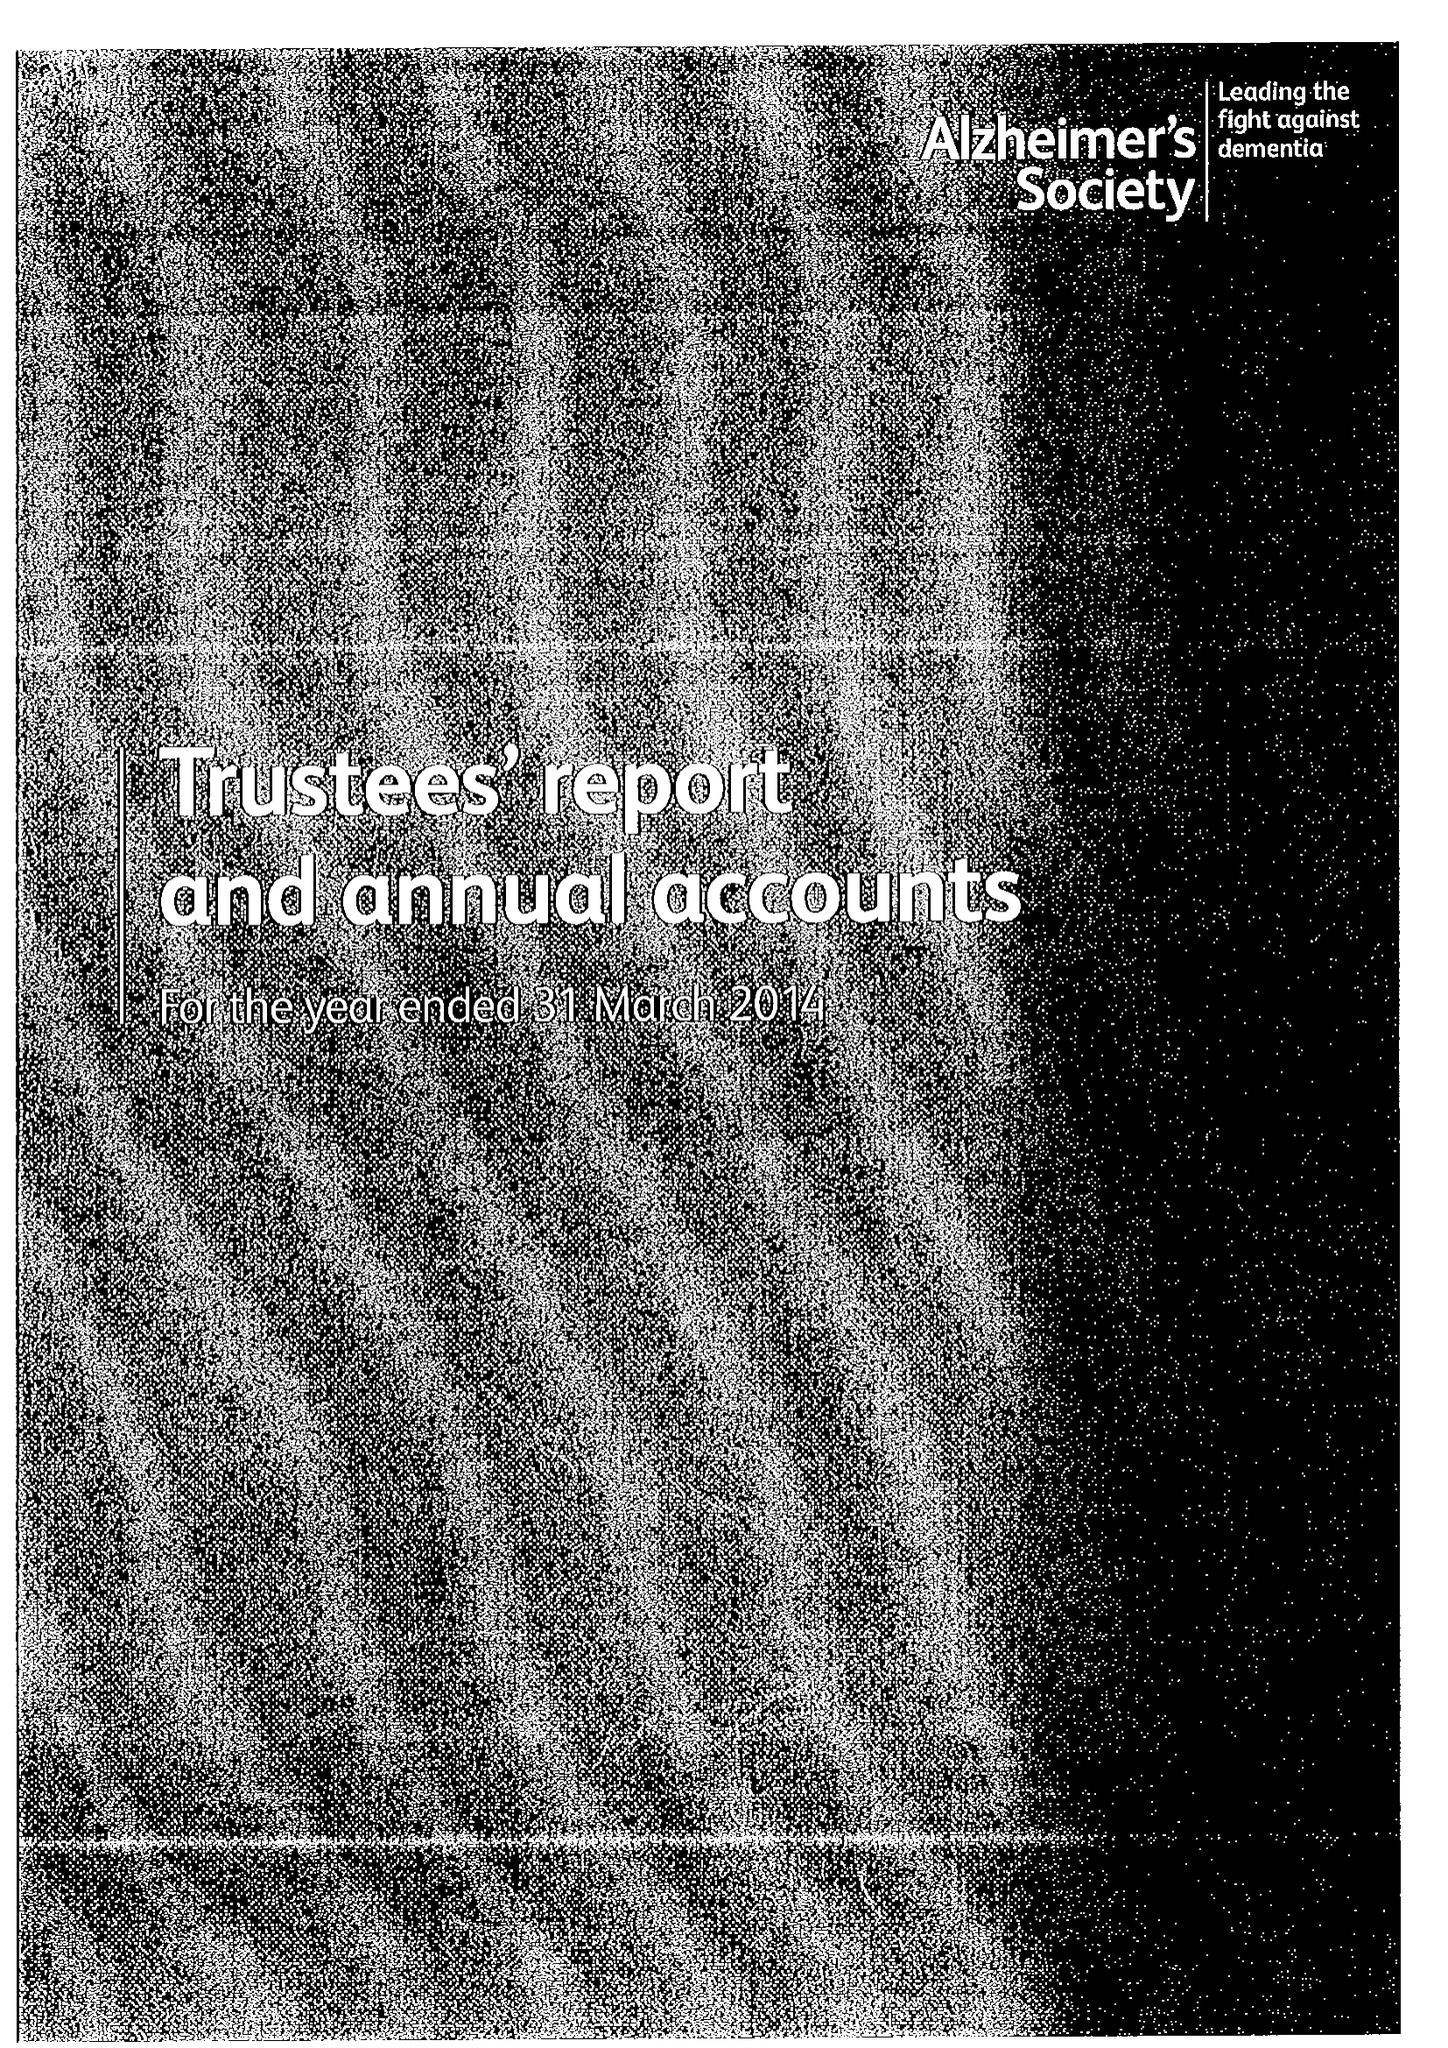What is the value for the report_date?
Answer the question using a single word or phrase. 2014-03-31 